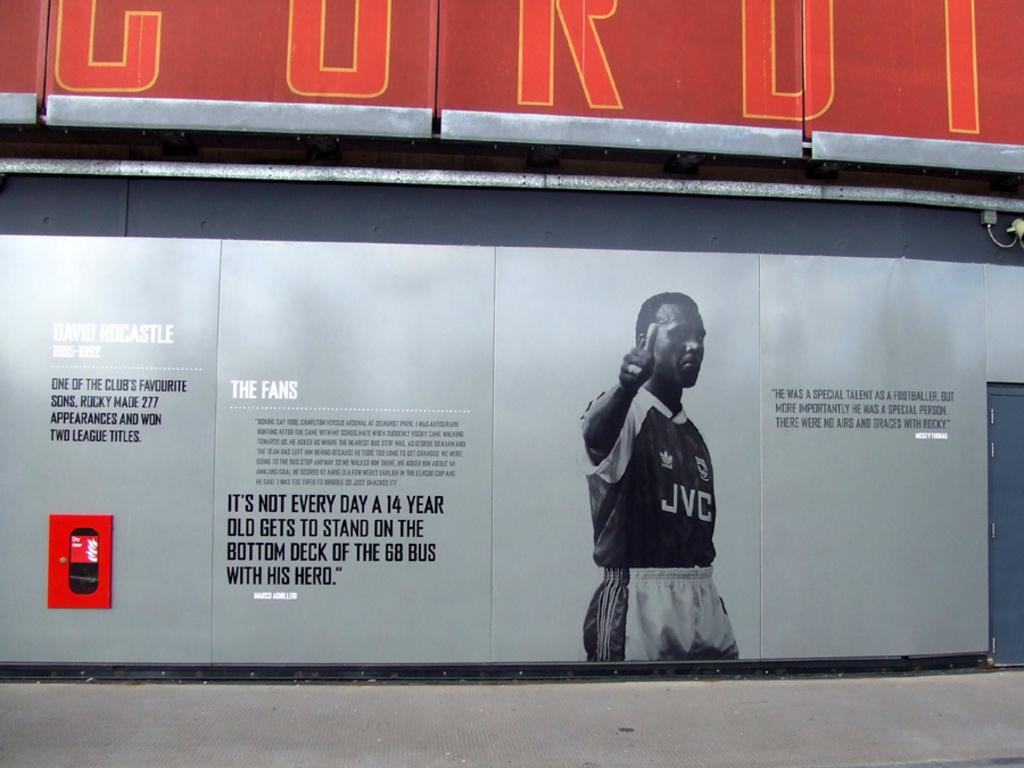Provide a one-sentence caption for the provided image. David Rocastle is depicted on a sign with the letters JVC on his shirt. 